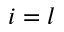<formula> <loc_0><loc_0><loc_500><loc_500>i = l</formula> 